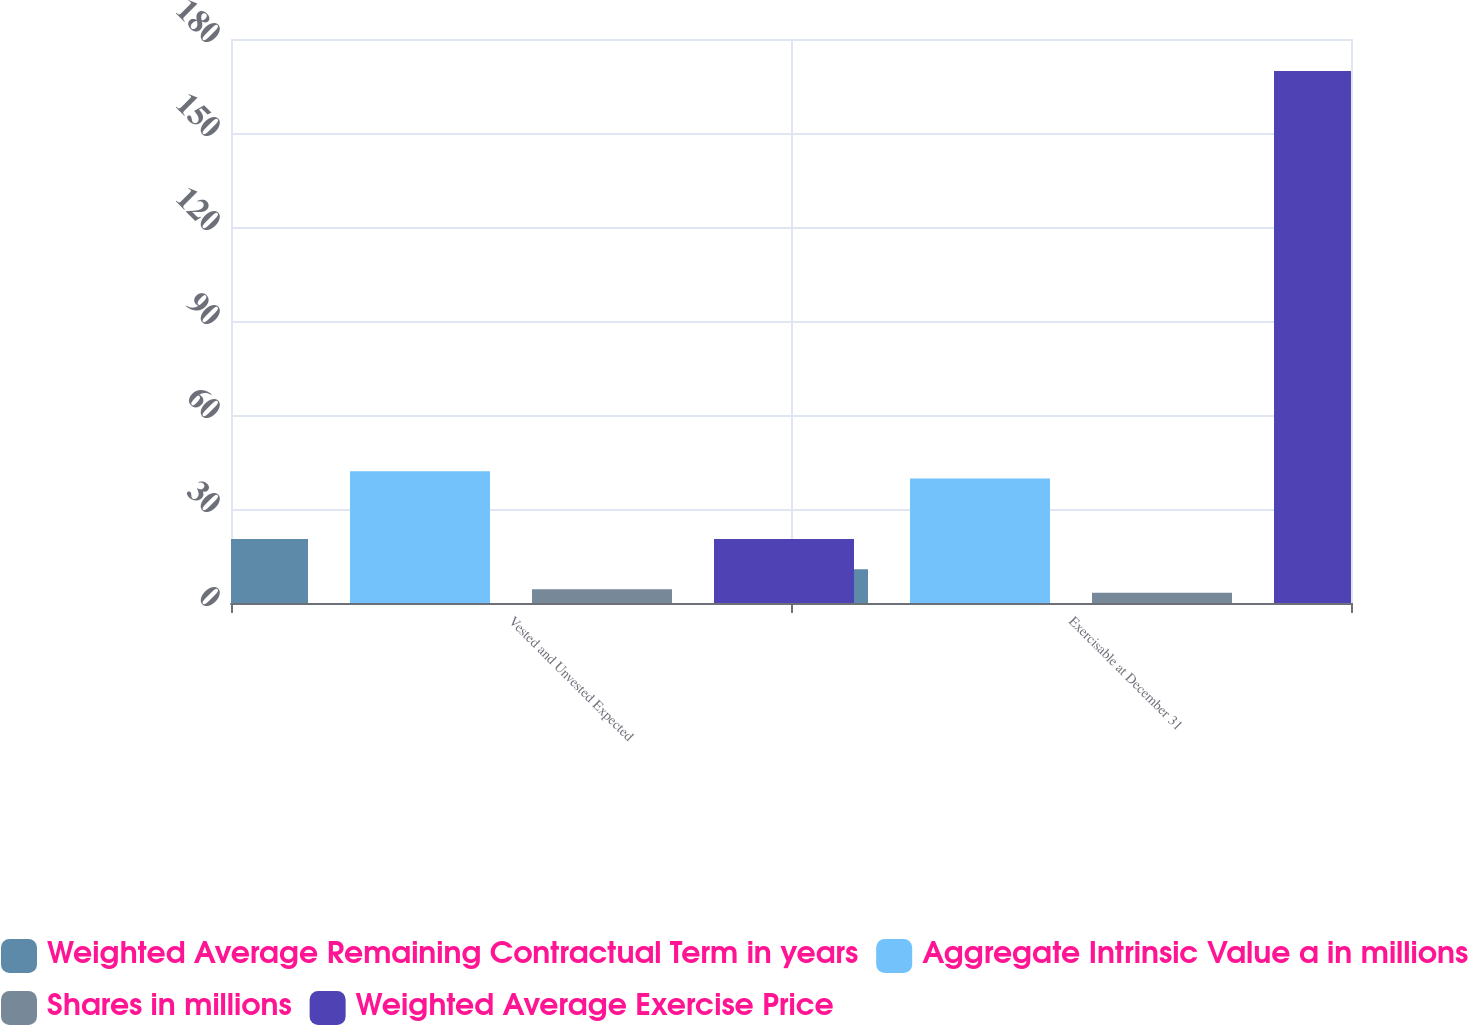Convert chart. <chart><loc_0><loc_0><loc_500><loc_500><stacked_bar_chart><ecel><fcel>Vested and Unvested Expected<fcel>Exercisable at December 31<nl><fcel>Weighted Average Remaining Contractual Term in years<fcel>20.4<fcel>10.8<nl><fcel>Aggregate Intrinsic Value a in millions<fcel>42.03<fcel>39.73<nl><fcel>Shares in millions<fcel>4.4<fcel>3.3<nl><fcel>Weighted Average Exercise Price<fcel>20.4<fcel>169.8<nl></chart> 